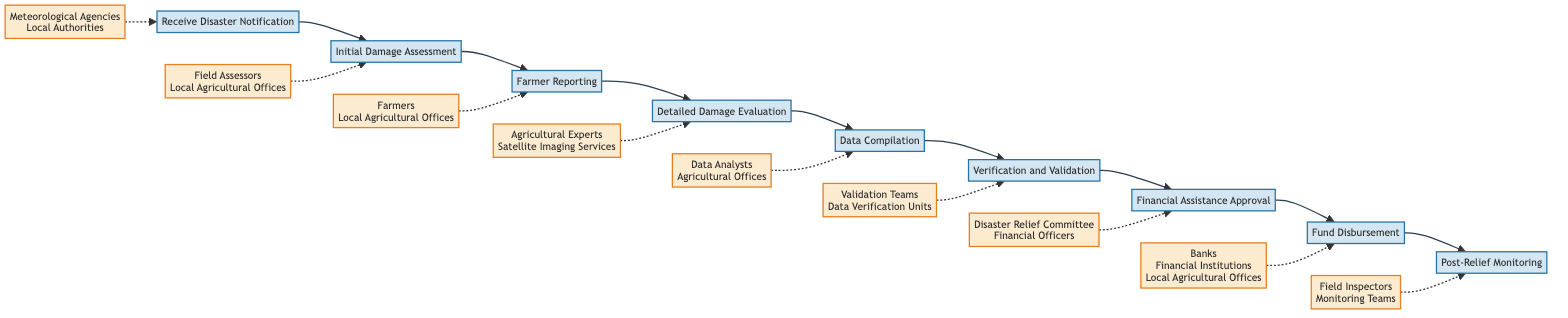What is the first step in the process? The first step in the process is indicated by the node at the beginning of the flowchart, which is "Receive Disaster Notification." This node does not have any preceding steps leading to it, making it the starting point.
Answer: Receive Disaster Notification Who is involved in the "Detailed Damage Evaluation"? In the node labeled "Detailed Damage Evaluation," the entities listed are "Agricultural Experts" and "Satellite Imaging Services." This information is provided directly below the title of the step.
Answer: Agricultural Experts, Satellite Imaging Services How many steps are in the process for assessing crop damage? By counting the nodes listed in the flowchart, there are a total of nine distinct steps involved in the process for assessing crop damage. Each step contributes to the overall workflow.
Answer: 9 What follows after "Data Compilation"? The flowchart shows that the step that follows "Data Compilation" is "Verification and Validation." This can be inferred by following the arrow leading out from the "Data Compilation" node.
Answer: Verification and Validation Which entities are responsible for "Fund Disbursement"? The node labeled "Fund Disbursement" lists "Banks," "Financial Institutions," and "Local Agricultural Offices" as the responsible entities. This information is specifically noted under the title of the step in the diagram.
Answer: Banks, Financial Institutions, Local Agricultural Offices What is required before "Financial Assistance Approval"? The step that must be completed before "Financial Assistance Approval" is "Verification and Validation." This can be seen by tracing the flow from one step to the next to establish the necessary sequence.
Answer: Verification and Validation Which two steps are directly connected to farmers? The steps directly connected to farmers are "Farmer Reporting" and "Initial Damage Assessment." "Farmer Reporting" involves farmers directly reporting claims, while "Initial Damage Assessment" involves assessing the effects of their reports.
Answer: Farmer Reporting, Initial Damage Assessment How do the entities for "Receive Disaster Notification" differ from those in "Post-Relief Monitoring"? The entities for "Receive Disaster Notification" include "Meteorological Agencies" and "Local Authorities." In contrast, "Post-Relief Monitoring" involves "Field Inspectors" and "Monitoring Teams." These distinctions illustrate the varying responsibilities across different stages of the process.
Answer: Meteorological Agencies, Local Authorities; Field Inspectors, Monitoring Teams What is the purpose of "Data Compilation"? The purpose of "Data Compilation" is to compile data collected from field assessments and farmer reports into a comprehensive damage report, which is articulated in the diagram under its title.
Answer: Compile data into a comprehensive damage report 